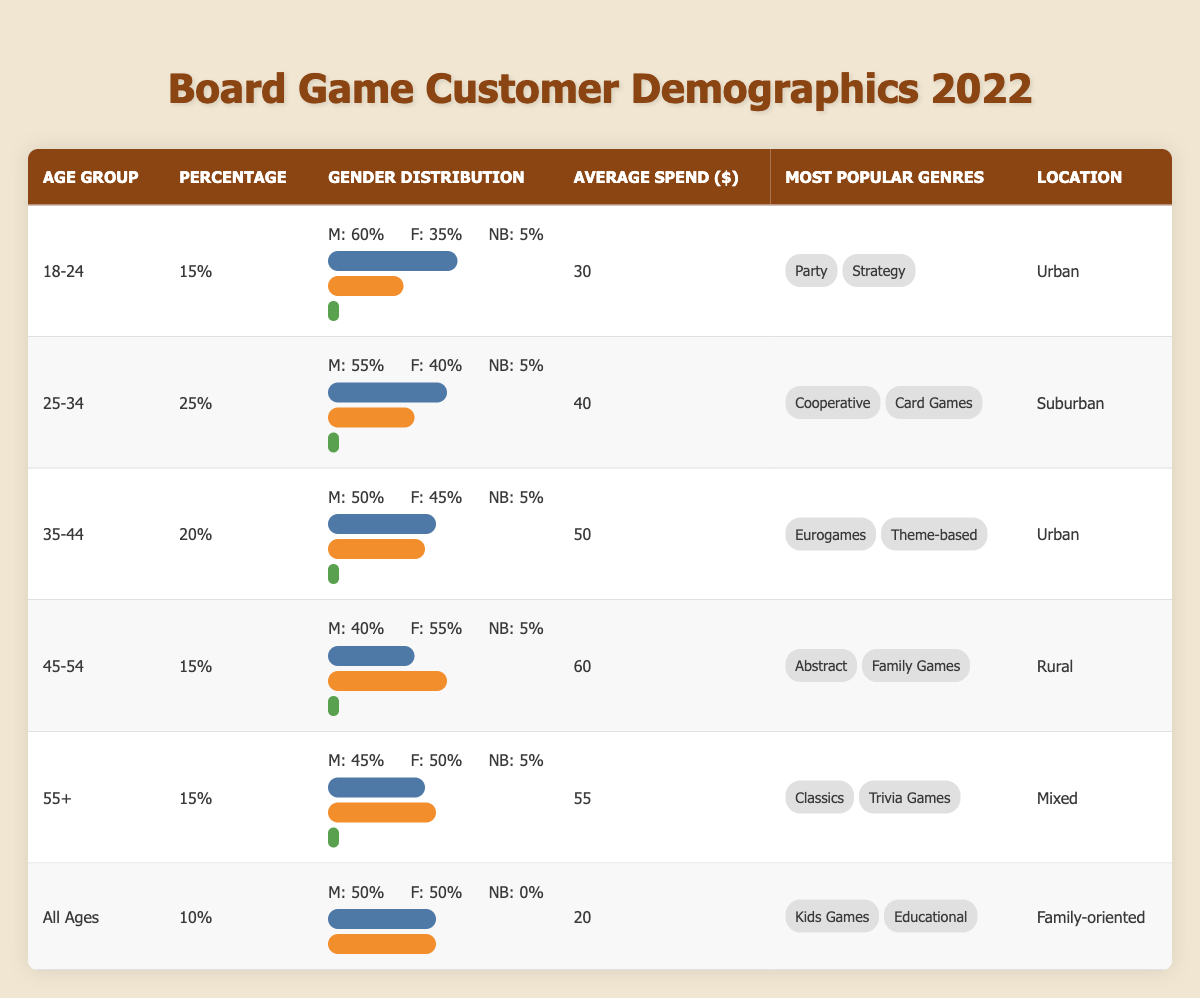What percentage of board game customers are aged 25-34? The demographic data shows that the percentage of customers aged 25-34 is directly listed in the table as 25%.
Answer: 25% What is the average spend of customers in the 45-54 age group? The average spend value for the 45-54 age group is directly mentioned in the table as $60.
Answer: 60 Are most board game customers located in urban areas? By examining the location column, we can see that three out of six age groups (18-24, 35-44) are noted to be from urban locations, which does indicate a significant presence, but since some groups are from suburban, rural, and mixed areas, the answer is not outright yes.
Answer: No What is the average spend across all age groups? To calculate the average spend across all age groups, add the average spends: 30 + 40 + 50 + 60 + 55 + 20 = 255, then divide by the number of groups (6), which gives 255 / 6 = 42.5.
Answer: 42.5 What is the most popular genre among customers aged 35-44? In the table, the most popular genres for the 35-44 age group are listed as Eurogames and Theme-based.
Answer: Eurogames, Theme-based Which age group has the highest percentage of female customers? By looking at the gender distribution for each age group, the highest percentage of female customers is in the 45-54 age group, where females make up 55%.
Answer: 45-54 What is the difference in average spend between the 18-24 and 25-34 age groups? The average spend for 18-24 is $30 and for 25-34 is $40. The difference is calculated as 40 - 30 = 10.
Answer: 10 Is the gender distribution of customers in the 55+ age group evenly split? The gender distribution data indicates 45% male and 50% female with 5% non-binary. Since the male and female percentages are not equal, the answer is no.
Answer: No How many age groups have an average spend greater than $50? By reviewing the average spend column, two age groups (45-54 with $60 and 35-44 with $50) are observed to have spends of $50 or more. Thus, the result is 2 age groups.
Answer: 2 